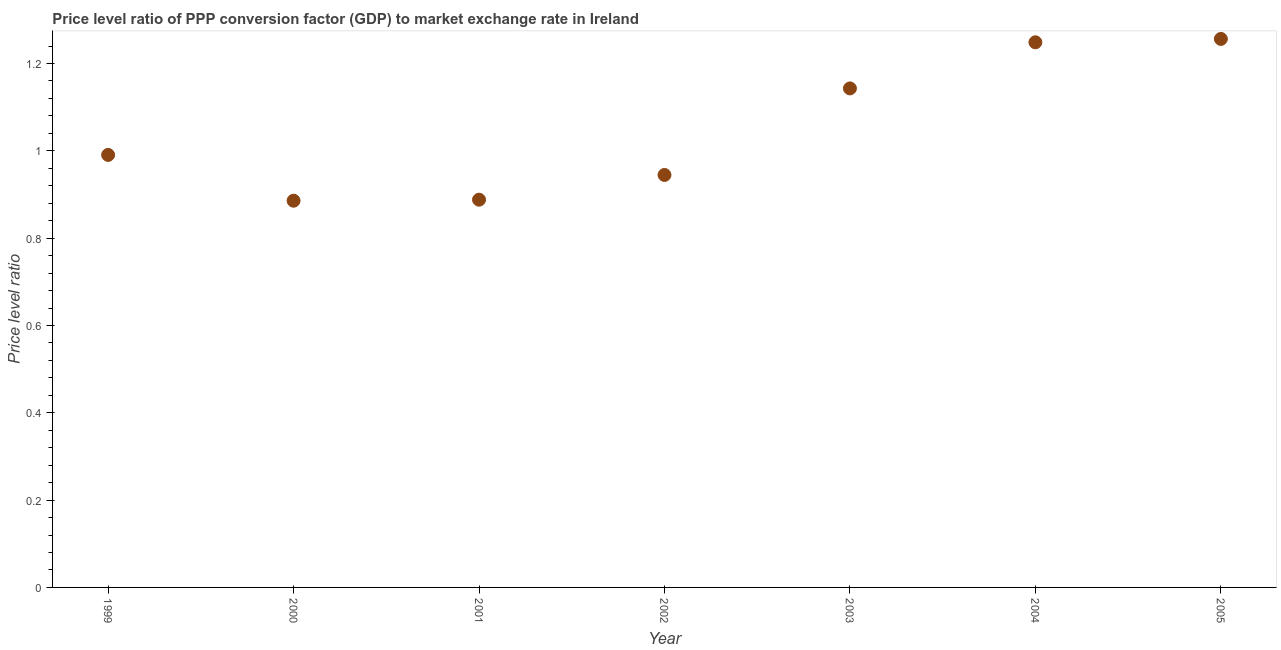What is the price level ratio in 2000?
Offer a terse response. 0.89. Across all years, what is the maximum price level ratio?
Ensure brevity in your answer.  1.26. Across all years, what is the minimum price level ratio?
Provide a short and direct response. 0.89. What is the sum of the price level ratio?
Make the answer very short. 7.36. What is the difference between the price level ratio in 2001 and 2002?
Offer a terse response. -0.06. What is the average price level ratio per year?
Keep it short and to the point. 1.05. What is the median price level ratio?
Make the answer very short. 0.99. In how many years, is the price level ratio greater than 0.16 ?
Provide a succinct answer. 7. Do a majority of the years between 2001 and 2000 (inclusive) have price level ratio greater than 1.2000000000000002 ?
Provide a succinct answer. No. What is the ratio of the price level ratio in 2004 to that in 2005?
Your answer should be very brief. 0.99. Is the price level ratio in 2000 less than that in 2004?
Keep it short and to the point. Yes. What is the difference between the highest and the second highest price level ratio?
Make the answer very short. 0.01. Is the sum of the price level ratio in 2001 and 2002 greater than the maximum price level ratio across all years?
Offer a very short reply. Yes. What is the difference between the highest and the lowest price level ratio?
Offer a terse response. 0.37. Does the price level ratio monotonically increase over the years?
Provide a short and direct response. No. Are the values on the major ticks of Y-axis written in scientific E-notation?
Provide a short and direct response. No. What is the title of the graph?
Your answer should be compact. Price level ratio of PPP conversion factor (GDP) to market exchange rate in Ireland. What is the label or title of the X-axis?
Your answer should be very brief. Year. What is the label or title of the Y-axis?
Your answer should be very brief. Price level ratio. What is the Price level ratio in 1999?
Ensure brevity in your answer.  0.99. What is the Price level ratio in 2000?
Offer a terse response. 0.89. What is the Price level ratio in 2001?
Keep it short and to the point. 0.89. What is the Price level ratio in 2002?
Ensure brevity in your answer.  0.94. What is the Price level ratio in 2003?
Keep it short and to the point. 1.14. What is the Price level ratio in 2004?
Your answer should be compact. 1.25. What is the Price level ratio in 2005?
Ensure brevity in your answer.  1.26. What is the difference between the Price level ratio in 1999 and 2000?
Provide a short and direct response. 0.1. What is the difference between the Price level ratio in 1999 and 2001?
Provide a succinct answer. 0.1. What is the difference between the Price level ratio in 1999 and 2002?
Your answer should be very brief. 0.05. What is the difference between the Price level ratio in 1999 and 2003?
Make the answer very short. -0.15. What is the difference between the Price level ratio in 1999 and 2004?
Give a very brief answer. -0.26. What is the difference between the Price level ratio in 1999 and 2005?
Provide a succinct answer. -0.27. What is the difference between the Price level ratio in 2000 and 2001?
Provide a succinct answer. -0. What is the difference between the Price level ratio in 2000 and 2002?
Make the answer very short. -0.06. What is the difference between the Price level ratio in 2000 and 2003?
Keep it short and to the point. -0.26. What is the difference between the Price level ratio in 2000 and 2004?
Provide a succinct answer. -0.36. What is the difference between the Price level ratio in 2000 and 2005?
Offer a very short reply. -0.37. What is the difference between the Price level ratio in 2001 and 2002?
Ensure brevity in your answer.  -0.06. What is the difference between the Price level ratio in 2001 and 2003?
Provide a short and direct response. -0.25. What is the difference between the Price level ratio in 2001 and 2004?
Make the answer very short. -0.36. What is the difference between the Price level ratio in 2001 and 2005?
Your response must be concise. -0.37. What is the difference between the Price level ratio in 2002 and 2003?
Your answer should be compact. -0.2. What is the difference between the Price level ratio in 2002 and 2004?
Your answer should be very brief. -0.3. What is the difference between the Price level ratio in 2002 and 2005?
Provide a succinct answer. -0.31. What is the difference between the Price level ratio in 2003 and 2004?
Provide a short and direct response. -0.11. What is the difference between the Price level ratio in 2003 and 2005?
Provide a succinct answer. -0.11. What is the difference between the Price level ratio in 2004 and 2005?
Ensure brevity in your answer.  -0.01. What is the ratio of the Price level ratio in 1999 to that in 2000?
Offer a terse response. 1.12. What is the ratio of the Price level ratio in 1999 to that in 2001?
Give a very brief answer. 1.11. What is the ratio of the Price level ratio in 1999 to that in 2002?
Provide a short and direct response. 1.05. What is the ratio of the Price level ratio in 1999 to that in 2003?
Make the answer very short. 0.87. What is the ratio of the Price level ratio in 1999 to that in 2004?
Your answer should be compact. 0.79. What is the ratio of the Price level ratio in 1999 to that in 2005?
Provide a short and direct response. 0.79. What is the ratio of the Price level ratio in 2000 to that in 2002?
Your response must be concise. 0.94. What is the ratio of the Price level ratio in 2000 to that in 2003?
Ensure brevity in your answer.  0.78. What is the ratio of the Price level ratio in 2000 to that in 2004?
Your answer should be compact. 0.71. What is the ratio of the Price level ratio in 2000 to that in 2005?
Your answer should be very brief. 0.7. What is the ratio of the Price level ratio in 2001 to that in 2003?
Your answer should be compact. 0.78. What is the ratio of the Price level ratio in 2001 to that in 2004?
Your answer should be very brief. 0.71. What is the ratio of the Price level ratio in 2001 to that in 2005?
Give a very brief answer. 0.71. What is the ratio of the Price level ratio in 2002 to that in 2003?
Give a very brief answer. 0.83. What is the ratio of the Price level ratio in 2002 to that in 2004?
Keep it short and to the point. 0.76. What is the ratio of the Price level ratio in 2002 to that in 2005?
Ensure brevity in your answer.  0.75. What is the ratio of the Price level ratio in 2003 to that in 2004?
Provide a succinct answer. 0.92. What is the ratio of the Price level ratio in 2003 to that in 2005?
Provide a succinct answer. 0.91. 